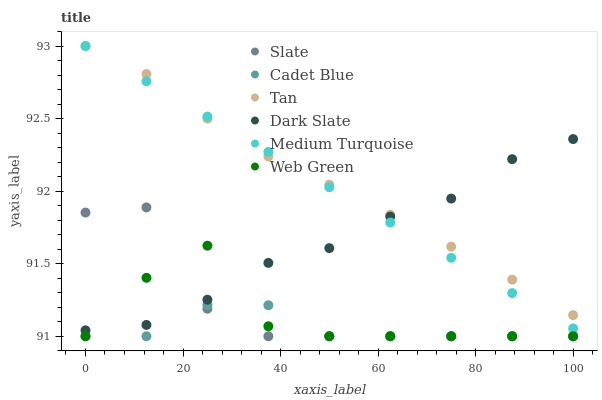Does Cadet Blue have the minimum area under the curve?
Answer yes or no. Yes. Does Tan have the maximum area under the curve?
Answer yes or no. Yes. Does Slate have the minimum area under the curve?
Answer yes or no. No. Does Slate have the maximum area under the curve?
Answer yes or no. No. Is Medium Turquoise the smoothest?
Answer yes or no. Yes. Is Web Green the roughest?
Answer yes or no. Yes. Is Slate the smoothest?
Answer yes or no. No. Is Slate the roughest?
Answer yes or no. No. Does Cadet Blue have the lowest value?
Answer yes or no. Yes. Does Dark Slate have the lowest value?
Answer yes or no. No. Does Tan have the highest value?
Answer yes or no. Yes. Does Slate have the highest value?
Answer yes or no. No. Is Cadet Blue less than Medium Turquoise?
Answer yes or no. Yes. Is Tan greater than Web Green?
Answer yes or no. Yes. Does Medium Turquoise intersect Dark Slate?
Answer yes or no. Yes. Is Medium Turquoise less than Dark Slate?
Answer yes or no. No. Is Medium Turquoise greater than Dark Slate?
Answer yes or no. No. Does Cadet Blue intersect Medium Turquoise?
Answer yes or no. No. 